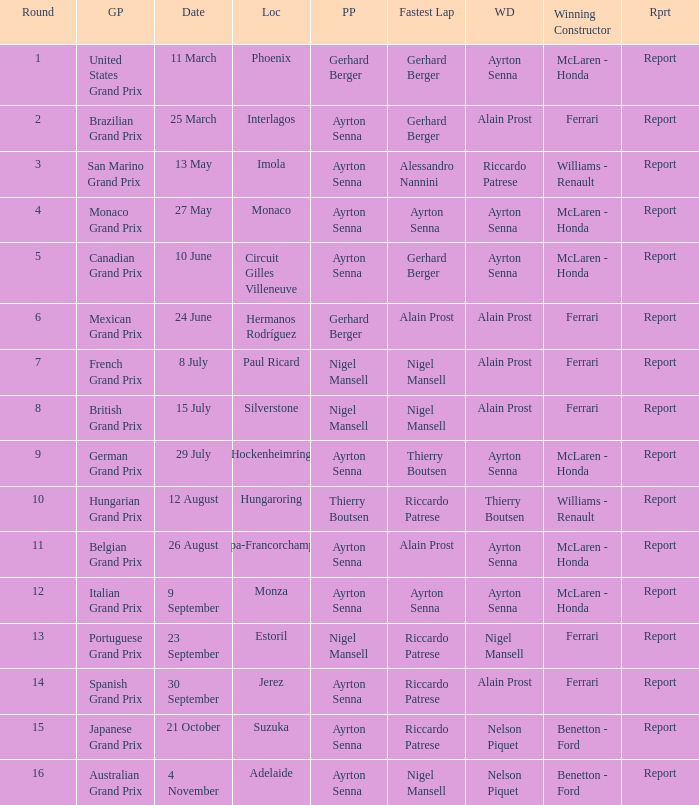Would you mind parsing the complete table? {'header': ['Round', 'GP', 'Date', 'Loc', 'PP', 'Fastest Lap', 'WD', 'Winning Constructor', 'Rprt'], 'rows': [['1', 'United States Grand Prix', '11 March', 'Phoenix', 'Gerhard Berger', 'Gerhard Berger', 'Ayrton Senna', 'McLaren - Honda', 'Report'], ['2', 'Brazilian Grand Prix', '25 March', 'Interlagos', 'Ayrton Senna', 'Gerhard Berger', 'Alain Prost', 'Ferrari', 'Report'], ['3', 'San Marino Grand Prix', '13 May', 'Imola', 'Ayrton Senna', 'Alessandro Nannini', 'Riccardo Patrese', 'Williams - Renault', 'Report'], ['4', 'Monaco Grand Prix', '27 May', 'Monaco', 'Ayrton Senna', 'Ayrton Senna', 'Ayrton Senna', 'McLaren - Honda', 'Report'], ['5', 'Canadian Grand Prix', '10 June', 'Circuit Gilles Villeneuve', 'Ayrton Senna', 'Gerhard Berger', 'Ayrton Senna', 'McLaren - Honda', 'Report'], ['6', 'Mexican Grand Prix', '24 June', 'Hermanos Rodríguez', 'Gerhard Berger', 'Alain Prost', 'Alain Prost', 'Ferrari', 'Report'], ['7', 'French Grand Prix', '8 July', 'Paul Ricard', 'Nigel Mansell', 'Nigel Mansell', 'Alain Prost', 'Ferrari', 'Report'], ['8', 'British Grand Prix', '15 July', 'Silverstone', 'Nigel Mansell', 'Nigel Mansell', 'Alain Prost', 'Ferrari', 'Report'], ['9', 'German Grand Prix', '29 July', 'Hockenheimring', 'Ayrton Senna', 'Thierry Boutsen', 'Ayrton Senna', 'McLaren - Honda', 'Report'], ['10', 'Hungarian Grand Prix', '12 August', 'Hungaroring', 'Thierry Boutsen', 'Riccardo Patrese', 'Thierry Boutsen', 'Williams - Renault', 'Report'], ['11', 'Belgian Grand Prix', '26 August', 'Spa-Francorchamps', 'Ayrton Senna', 'Alain Prost', 'Ayrton Senna', 'McLaren - Honda', 'Report'], ['12', 'Italian Grand Prix', '9 September', 'Monza', 'Ayrton Senna', 'Ayrton Senna', 'Ayrton Senna', 'McLaren - Honda', 'Report'], ['13', 'Portuguese Grand Prix', '23 September', 'Estoril', 'Nigel Mansell', 'Riccardo Patrese', 'Nigel Mansell', 'Ferrari', 'Report'], ['14', 'Spanish Grand Prix', '30 September', 'Jerez', 'Ayrton Senna', 'Riccardo Patrese', 'Alain Prost', 'Ferrari', 'Report'], ['15', 'Japanese Grand Prix', '21 October', 'Suzuka', 'Ayrton Senna', 'Riccardo Patrese', 'Nelson Piquet', 'Benetton - Ford', 'Report'], ['16', 'Australian Grand Prix', '4 November', 'Adelaide', 'Ayrton Senna', 'Nigel Mansell', 'Nelson Piquet', 'Benetton - Ford', 'Report']]} What is the Pole Position for the German Grand Prix Ayrton Senna. 